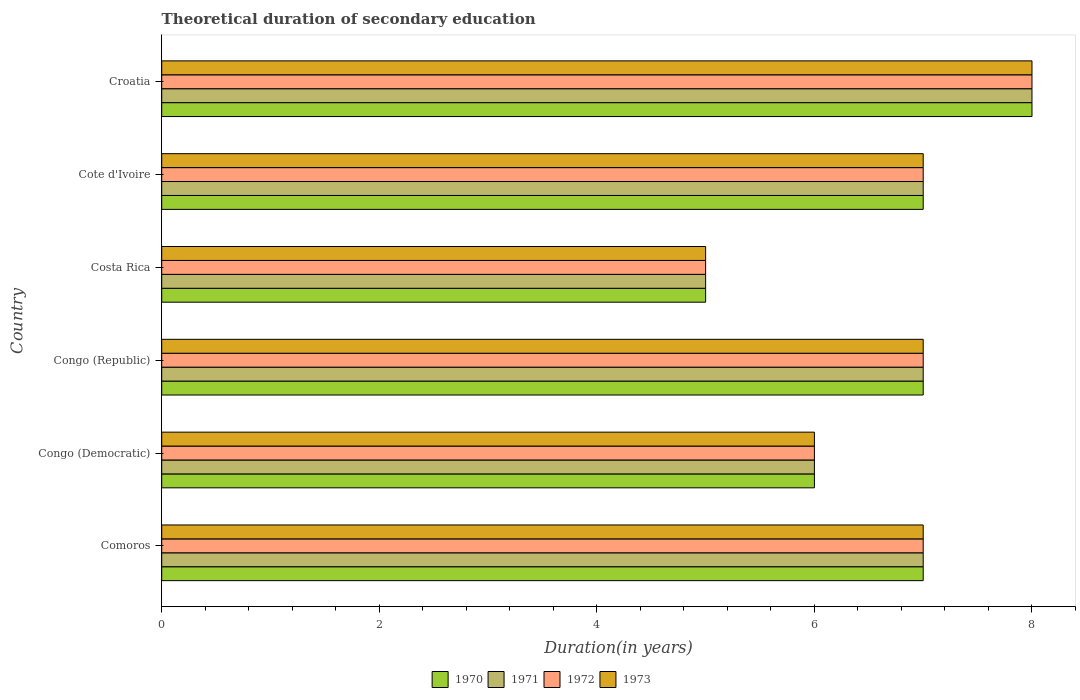How many groups of bars are there?
Offer a terse response. 6. How many bars are there on the 6th tick from the top?
Your answer should be very brief. 4. How many bars are there on the 4th tick from the bottom?
Provide a succinct answer. 4. What is the label of the 5th group of bars from the top?
Provide a short and direct response. Congo (Democratic). In how many cases, is the number of bars for a given country not equal to the number of legend labels?
Make the answer very short. 0. What is the total theoretical duration of secondary education in 1973 in Costa Rica?
Give a very brief answer. 5. Across all countries, what is the minimum total theoretical duration of secondary education in 1970?
Your answer should be very brief. 5. In which country was the total theoretical duration of secondary education in 1970 maximum?
Provide a short and direct response. Croatia. In which country was the total theoretical duration of secondary education in 1972 minimum?
Provide a short and direct response. Costa Rica. What is the difference between the total theoretical duration of secondary education in 1970 in Comoros and that in Congo (Republic)?
Offer a terse response. 0. What is the average total theoretical duration of secondary education in 1973 per country?
Give a very brief answer. 6.67. What is the difference between the total theoretical duration of secondary education in 1973 and total theoretical duration of secondary education in 1972 in Congo (Democratic)?
Give a very brief answer. 0. In how many countries, is the total theoretical duration of secondary education in 1970 greater than 6 years?
Provide a short and direct response. 4. Is the difference between the total theoretical duration of secondary education in 1973 in Costa Rica and Croatia greater than the difference between the total theoretical duration of secondary education in 1972 in Costa Rica and Croatia?
Your answer should be very brief. No. What is the difference between the highest and the second highest total theoretical duration of secondary education in 1973?
Ensure brevity in your answer.  1. What is the difference between the highest and the lowest total theoretical duration of secondary education in 1971?
Keep it short and to the point. 3. In how many countries, is the total theoretical duration of secondary education in 1971 greater than the average total theoretical duration of secondary education in 1971 taken over all countries?
Give a very brief answer. 4. Is the sum of the total theoretical duration of secondary education in 1971 in Congo (Republic) and Cote d'Ivoire greater than the maximum total theoretical duration of secondary education in 1972 across all countries?
Your answer should be compact. Yes. How many bars are there?
Offer a terse response. 24. How many countries are there in the graph?
Your answer should be compact. 6. What is the difference between two consecutive major ticks on the X-axis?
Your answer should be very brief. 2. Does the graph contain grids?
Provide a short and direct response. No. Where does the legend appear in the graph?
Keep it short and to the point. Bottom center. How many legend labels are there?
Keep it short and to the point. 4. How are the legend labels stacked?
Your response must be concise. Horizontal. What is the title of the graph?
Your response must be concise. Theoretical duration of secondary education. Does "1993" appear as one of the legend labels in the graph?
Offer a terse response. No. What is the label or title of the X-axis?
Provide a short and direct response. Duration(in years). What is the Duration(in years) in 1971 in Comoros?
Provide a short and direct response. 7. What is the Duration(in years) of 1972 in Comoros?
Give a very brief answer. 7. What is the Duration(in years) of 1973 in Comoros?
Your answer should be very brief. 7. What is the Duration(in years) of 1970 in Congo (Democratic)?
Your answer should be compact. 6. What is the Duration(in years) of 1971 in Congo (Democratic)?
Offer a terse response. 6. What is the Duration(in years) of 1971 in Congo (Republic)?
Offer a very short reply. 7. What is the Duration(in years) in 1971 in Costa Rica?
Ensure brevity in your answer.  5. What is the Duration(in years) of 1972 in Costa Rica?
Provide a short and direct response. 5. What is the Duration(in years) of 1973 in Costa Rica?
Your answer should be very brief. 5. What is the Duration(in years) in 1970 in Cote d'Ivoire?
Provide a short and direct response. 7. What is the Duration(in years) of 1970 in Croatia?
Offer a terse response. 8. What is the Duration(in years) in 1971 in Croatia?
Offer a very short reply. 8. What is the Duration(in years) of 1972 in Croatia?
Keep it short and to the point. 8. Across all countries, what is the maximum Duration(in years) in 1970?
Make the answer very short. 8. Across all countries, what is the maximum Duration(in years) of 1972?
Keep it short and to the point. 8. Across all countries, what is the maximum Duration(in years) of 1973?
Your answer should be compact. 8. What is the total Duration(in years) of 1970 in the graph?
Provide a succinct answer. 40. What is the total Duration(in years) of 1971 in the graph?
Give a very brief answer. 40. What is the total Duration(in years) of 1972 in the graph?
Provide a short and direct response. 40. What is the total Duration(in years) of 1973 in the graph?
Give a very brief answer. 40. What is the difference between the Duration(in years) in 1972 in Comoros and that in Congo (Democratic)?
Keep it short and to the point. 1. What is the difference between the Duration(in years) in 1973 in Comoros and that in Congo (Democratic)?
Provide a succinct answer. 1. What is the difference between the Duration(in years) of 1970 in Comoros and that in Congo (Republic)?
Keep it short and to the point. 0. What is the difference between the Duration(in years) of 1971 in Comoros and that in Congo (Republic)?
Offer a terse response. 0. What is the difference between the Duration(in years) of 1973 in Comoros and that in Congo (Republic)?
Give a very brief answer. 0. What is the difference between the Duration(in years) in 1973 in Comoros and that in Costa Rica?
Offer a very short reply. 2. What is the difference between the Duration(in years) in 1971 in Comoros and that in Cote d'Ivoire?
Your answer should be compact. 0. What is the difference between the Duration(in years) in 1973 in Comoros and that in Cote d'Ivoire?
Provide a succinct answer. 0. What is the difference between the Duration(in years) in 1970 in Comoros and that in Croatia?
Provide a short and direct response. -1. What is the difference between the Duration(in years) in 1971 in Comoros and that in Croatia?
Provide a succinct answer. -1. What is the difference between the Duration(in years) in 1971 in Congo (Democratic) and that in Congo (Republic)?
Keep it short and to the point. -1. What is the difference between the Duration(in years) of 1972 in Congo (Democratic) and that in Congo (Republic)?
Offer a very short reply. -1. What is the difference between the Duration(in years) of 1973 in Congo (Democratic) and that in Congo (Republic)?
Give a very brief answer. -1. What is the difference between the Duration(in years) of 1970 in Congo (Democratic) and that in Cote d'Ivoire?
Your response must be concise. -1. What is the difference between the Duration(in years) of 1971 in Congo (Democratic) and that in Cote d'Ivoire?
Your response must be concise. -1. What is the difference between the Duration(in years) of 1972 in Congo (Democratic) and that in Cote d'Ivoire?
Offer a very short reply. -1. What is the difference between the Duration(in years) of 1970 in Congo (Democratic) and that in Croatia?
Your answer should be very brief. -2. What is the difference between the Duration(in years) in 1971 in Congo (Democratic) and that in Croatia?
Your answer should be compact. -2. What is the difference between the Duration(in years) of 1971 in Congo (Republic) and that in Costa Rica?
Provide a short and direct response. 2. What is the difference between the Duration(in years) in 1972 in Congo (Republic) and that in Costa Rica?
Make the answer very short. 2. What is the difference between the Duration(in years) of 1973 in Congo (Republic) and that in Costa Rica?
Keep it short and to the point. 2. What is the difference between the Duration(in years) of 1970 in Congo (Republic) and that in Cote d'Ivoire?
Give a very brief answer. 0. What is the difference between the Duration(in years) in 1972 in Congo (Republic) and that in Cote d'Ivoire?
Offer a terse response. 0. What is the difference between the Duration(in years) in 1973 in Congo (Republic) and that in Cote d'Ivoire?
Provide a succinct answer. 0. What is the difference between the Duration(in years) of 1970 in Congo (Republic) and that in Croatia?
Provide a short and direct response. -1. What is the difference between the Duration(in years) of 1973 in Congo (Republic) and that in Croatia?
Provide a short and direct response. -1. What is the difference between the Duration(in years) of 1970 in Costa Rica and that in Cote d'Ivoire?
Your answer should be compact. -2. What is the difference between the Duration(in years) of 1971 in Costa Rica and that in Cote d'Ivoire?
Keep it short and to the point. -2. What is the difference between the Duration(in years) in 1970 in Costa Rica and that in Croatia?
Provide a short and direct response. -3. What is the difference between the Duration(in years) in 1971 in Costa Rica and that in Croatia?
Provide a short and direct response. -3. What is the difference between the Duration(in years) in 1973 in Costa Rica and that in Croatia?
Your answer should be compact. -3. What is the difference between the Duration(in years) of 1973 in Cote d'Ivoire and that in Croatia?
Provide a succinct answer. -1. What is the difference between the Duration(in years) in 1970 in Comoros and the Duration(in years) in 1971 in Congo (Democratic)?
Provide a short and direct response. 1. What is the difference between the Duration(in years) of 1971 in Comoros and the Duration(in years) of 1972 in Congo (Democratic)?
Ensure brevity in your answer.  1. What is the difference between the Duration(in years) in 1971 in Comoros and the Duration(in years) in 1973 in Congo (Democratic)?
Provide a succinct answer. 1. What is the difference between the Duration(in years) of 1972 in Comoros and the Duration(in years) of 1973 in Congo (Democratic)?
Keep it short and to the point. 1. What is the difference between the Duration(in years) of 1970 in Comoros and the Duration(in years) of 1972 in Congo (Republic)?
Ensure brevity in your answer.  0. What is the difference between the Duration(in years) in 1970 in Comoros and the Duration(in years) in 1973 in Congo (Republic)?
Make the answer very short. 0. What is the difference between the Duration(in years) in 1970 in Comoros and the Duration(in years) in 1971 in Costa Rica?
Give a very brief answer. 2. What is the difference between the Duration(in years) in 1970 in Comoros and the Duration(in years) in 1972 in Cote d'Ivoire?
Make the answer very short. 0. What is the difference between the Duration(in years) of 1970 in Comoros and the Duration(in years) of 1971 in Croatia?
Offer a terse response. -1. What is the difference between the Duration(in years) of 1970 in Comoros and the Duration(in years) of 1972 in Croatia?
Offer a very short reply. -1. What is the difference between the Duration(in years) of 1971 in Comoros and the Duration(in years) of 1972 in Croatia?
Make the answer very short. -1. What is the difference between the Duration(in years) of 1971 in Comoros and the Duration(in years) of 1973 in Croatia?
Your response must be concise. -1. What is the difference between the Duration(in years) in 1970 in Congo (Democratic) and the Duration(in years) in 1973 in Congo (Republic)?
Offer a very short reply. -1. What is the difference between the Duration(in years) in 1970 in Congo (Democratic) and the Duration(in years) in 1971 in Costa Rica?
Your answer should be very brief. 1. What is the difference between the Duration(in years) in 1970 in Congo (Democratic) and the Duration(in years) in 1972 in Costa Rica?
Provide a succinct answer. 1. What is the difference between the Duration(in years) in 1970 in Congo (Democratic) and the Duration(in years) in 1971 in Cote d'Ivoire?
Keep it short and to the point. -1. What is the difference between the Duration(in years) of 1970 in Congo (Democratic) and the Duration(in years) of 1971 in Croatia?
Offer a very short reply. -2. What is the difference between the Duration(in years) in 1971 in Congo (Democratic) and the Duration(in years) in 1972 in Croatia?
Make the answer very short. -2. What is the difference between the Duration(in years) of 1971 in Congo (Democratic) and the Duration(in years) of 1973 in Croatia?
Provide a succinct answer. -2. What is the difference between the Duration(in years) of 1970 in Congo (Republic) and the Duration(in years) of 1972 in Costa Rica?
Offer a very short reply. 2. What is the difference between the Duration(in years) in 1971 in Congo (Republic) and the Duration(in years) in 1972 in Costa Rica?
Provide a succinct answer. 2. What is the difference between the Duration(in years) of 1971 in Congo (Republic) and the Duration(in years) of 1973 in Costa Rica?
Your response must be concise. 2. What is the difference between the Duration(in years) of 1970 in Congo (Republic) and the Duration(in years) of 1971 in Cote d'Ivoire?
Provide a succinct answer. 0. What is the difference between the Duration(in years) in 1970 in Congo (Republic) and the Duration(in years) in 1972 in Cote d'Ivoire?
Offer a terse response. 0. What is the difference between the Duration(in years) of 1970 in Congo (Republic) and the Duration(in years) of 1973 in Cote d'Ivoire?
Ensure brevity in your answer.  0. What is the difference between the Duration(in years) in 1972 in Congo (Republic) and the Duration(in years) in 1973 in Croatia?
Ensure brevity in your answer.  -1. What is the difference between the Duration(in years) in 1970 in Costa Rica and the Duration(in years) in 1972 in Cote d'Ivoire?
Provide a short and direct response. -2. What is the difference between the Duration(in years) in 1970 in Costa Rica and the Duration(in years) in 1973 in Cote d'Ivoire?
Ensure brevity in your answer.  -2. What is the difference between the Duration(in years) of 1972 in Costa Rica and the Duration(in years) of 1973 in Cote d'Ivoire?
Provide a succinct answer. -2. What is the difference between the Duration(in years) in 1970 in Costa Rica and the Duration(in years) in 1971 in Croatia?
Ensure brevity in your answer.  -3. What is the difference between the Duration(in years) of 1970 in Costa Rica and the Duration(in years) of 1972 in Croatia?
Your response must be concise. -3. What is the difference between the Duration(in years) in 1970 in Costa Rica and the Duration(in years) in 1973 in Croatia?
Ensure brevity in your answer.  -3. What is the difference between the Duration(in years) in 1970 in Cote d'Ivoire and the Duration(in years) in 1971 in Croatia?
Provide a succinct answer. -1. What is the difference between the Duration(in years) in 1970 in Cote d'Ivoire and the Duration(in years) in 1972 in Croatia?
Make the answer very short. -1. What is the difference between the Duration(in years) in 1971 in Cote d'Ivoire and the Duration(in years) in 1972 in Croatia?
Make the answer very short. -1. What is the difference between the Duration(in years) in 1972 in Cote d'Ivoire and the Duration(in years) in 1973 in Croatia?
Your answer should be very brief. -1. What is the average Duration(in years) in 1970 per country?
Keep it short and to the point. 6.67. What is the average Duration(in years) in 1972 per country?
Provide a short and direct response. 6.67. What is the difference between the Duration(in years) in 1970 and Duration(in years) in 1972 in Comoros?
Keep it short and to the point. 0. What is the difference between the Duration(in years) in 1971 and Duration(in years) in 1973 in Comoros?
Keep it short and to the point. 0. What is the difference between the Duration(in years) of 1970 and Duration(in years) of 1971 in Congo (Democratic)?
Your answer should be very brief. 0. What is the difference between the Duration(in years) of 1970 and Duration(in years) of 1973 in Congo (Democratic)?
Your answer should be compact. 0. What is the difference between the Duration(in years) in 1971 and Duration(in years) in 1972 in Congo (Democratic)?
Your response must be concise. 0. What is the difference between the Duration(in years) in 1971 and Duration(in years) in 1973 in Congo (Democratic)?
Make the answer very short. 0. What is the difference between the Duration(in years) in 1971 and Duration(in years) in 1972 in Congo (Republic)?
Offer a very short reply. 0. What is the difference between the Duration(in years) of 1971 and Duration(in years) of 1973 in Congo (Republic)?
Keep it short and to the point. 0. What is the difference between the Duration(in years) in 1970 and Duration(in years) in 1971 in Costa Rica?
Provide a succinct answer. 0. What is the difference between the Duration(in years) of 1970 and Duration(in years) of 1972 in Costa Rica?
Ensure brevity in your answer.  0. What is the difference between the Duration(in years) in 1971 and Duration(in years) in 1972 in Costa Rica?
Ensure brevity in your answer.  0. What is the difference between the Duration(in years) in 1970 and Duration(in years) in 1972 in Croatia?
Make the answer very short. 0. What is the difference between the Duration(in years) of 1970 and Duration(in years) of 1973 in Croatia?
Provide a short and direct response. 0. What is the difference between the Duration(in years) of 1971 and Duration(in years) of 1972 in Croatia?
Ensure brevity in your answer.  0. What is the difference between the Duration(in years) of 1971 and Duration(in years) of 1973 in Croatia?
Your answer should be compact. 0. What is the difference between the Duration(in years) in 1972 and Duration(in years) in 1973 in Croatia?
Ensure brevity in your answer.  0. What is the ratio of the Duration(in years) in 1972 in Comoros to that in Congo (Democratic)?
Offer a terse response. 1.17. What is the ratio of the Duration(in years) of 1970 in Comoros to that in Congo (Republic)?
Offer a terse response. 1. What is the ratio of the Duration(in years) in 1971 in Comoros to that in Congo (Republic)?
Provide a short and direct response. 1. What is the ratio of the Duration(in years) in 1973 in Comoros to that in Congo (Republic)?
Your answer should be very brief. 1. What is the ratio of the Duration(in years) of 1971 in Comoros to that in Costa Rica?
Offer a terse response. 1.4. What is the ratio of the Duration(in years) of 1970 in Comoros to that in Cote d'Ivoire?
Make the answer very short. 1. What is the ratio of the Duration(in years) in 1971 in Comoros to that in Cote d'Ivoire?
Offer a terse response. 1. What is the ratio of the Duration(in years) of 1973 in Comoros to that in Cote d'Ivoire?
Offer a terse response. 1. What is the ratio of the Duration(in years) in 1972 in Comoros to that in Croatia?
Give a very brief answer. 0.88. What is the ratio of the Duration(in years) of 1970 in Congo (Democratic) to that in Congo (Republic)?
Provide a succinct answer. 0.86. What is the ratio of the Duration(in years) of 1971 in Congo (Democratic) to that in Congo (Republic)?
Your answer should be compact. 0.86. What is the ratio of the Duration(in years) of 1972 in Congo (Democratic) to that in Congo (Republic)?
Your answer should be very brief. 0.86. What is the ratio of the Duration(in years) in 1973 in Congo (Democratic) to that in Congo (Republic)?
Your answer should be compact. 0.86. What is the ratio of the Duration(in years) of 1970 in Congo (Democratic) to that in Costa Rica?
Your answer should be compact. 1.2. What is the ratio of the Duration(in years) of 1971 in Congo (Democratic) to that in Costa Rica?
Give a very brief answer. 1.2. What is the ratio of the Duration(in years) of 1973 in Congo (Democratic) to that in Costa Rica?
Offer a terse response. 1.2. What is the ratio of the Duration(in years) of 1971 in Congo (Democratic) to that in Cote d'Ivoire?
Ensure brevity in your answer.  0.86. What is the ratio of the Duration(in years) of 1971 in Congo (Democratic) to that in Croatia?
Provide a short and direct response. 0.75. What is the ratio of the Duration(in years) in 1973 in Congo (Democratic) to that in Croatia?
Offer a terse response. 0.75. What is the ratio of the Duration(in years) in 1970 in Congo (Republic) to that in Costa Rica?
Give a very brief answer. 1.4. What is the ratio of the Duration(in years) in 1972 in Congo (Republic) to that in Costa Rica?
Make the answer very short. 1.4. What is the ratio of the Duration(in years) of 1973 in Congo (Republic) to that in Costa Rica?
Provide a succinct answer. 1.4. What is the ratio of the Duration(in years) in 1972 in Congo (Republic) to that in Cote d'Ivoire?
Ensure brevity in your answer.  1. What is the ratio of the Duration(in years) of 1971 in Congo (Republic) to that in Croatia?
Give a very brief answer. 0.88. What is the ratio of the Duration(in years) of 1972 in Congo (Republic) to that in Croatia?
Offer a very short reply. 0.88. What is the ratio of the Duration(in years) of 1973 in Congo (Republic) to that in Croatia?
Provide a succinct answer. 0.88. What is the ratio of the Duration(in years) in 1970 in Costa Rica to that in Cote d'Ivoire?
Provide a short and direct response. 0.71. What is the ratio of the Duration(in years) of 1971 in Costa Rica to that in Cote d'Ivoire?
Provide a succinct answer. 0.71. What is the ratio of the Duration(in years) of 1972 in Costa Rica to that in Cote d'Ivoire?
Your answer should be very brief. 0.71. What is the ratio of the Duration(in years) in 1973 in Costa Rica to that in Cote d'Ivoire?
Give a very brief answer. 0.71. What is the ratio of the Duration(in years) in 1971 in Costa Rica to that in Croatia?
Ensure brevity in your answer.  0.62. What is the ratio of the Duration(in years) in 1970 in Cote d'Ivoire to that in Croatia?
Give a very brief answer. 0.88. What is the difference between the highest and the second highest Duration(in years) of 1970?
Make the answer very short. 1. What is the difference between the highest and the lowest Duration(in years) in 1973?
Keep it short and to the point. 3. 